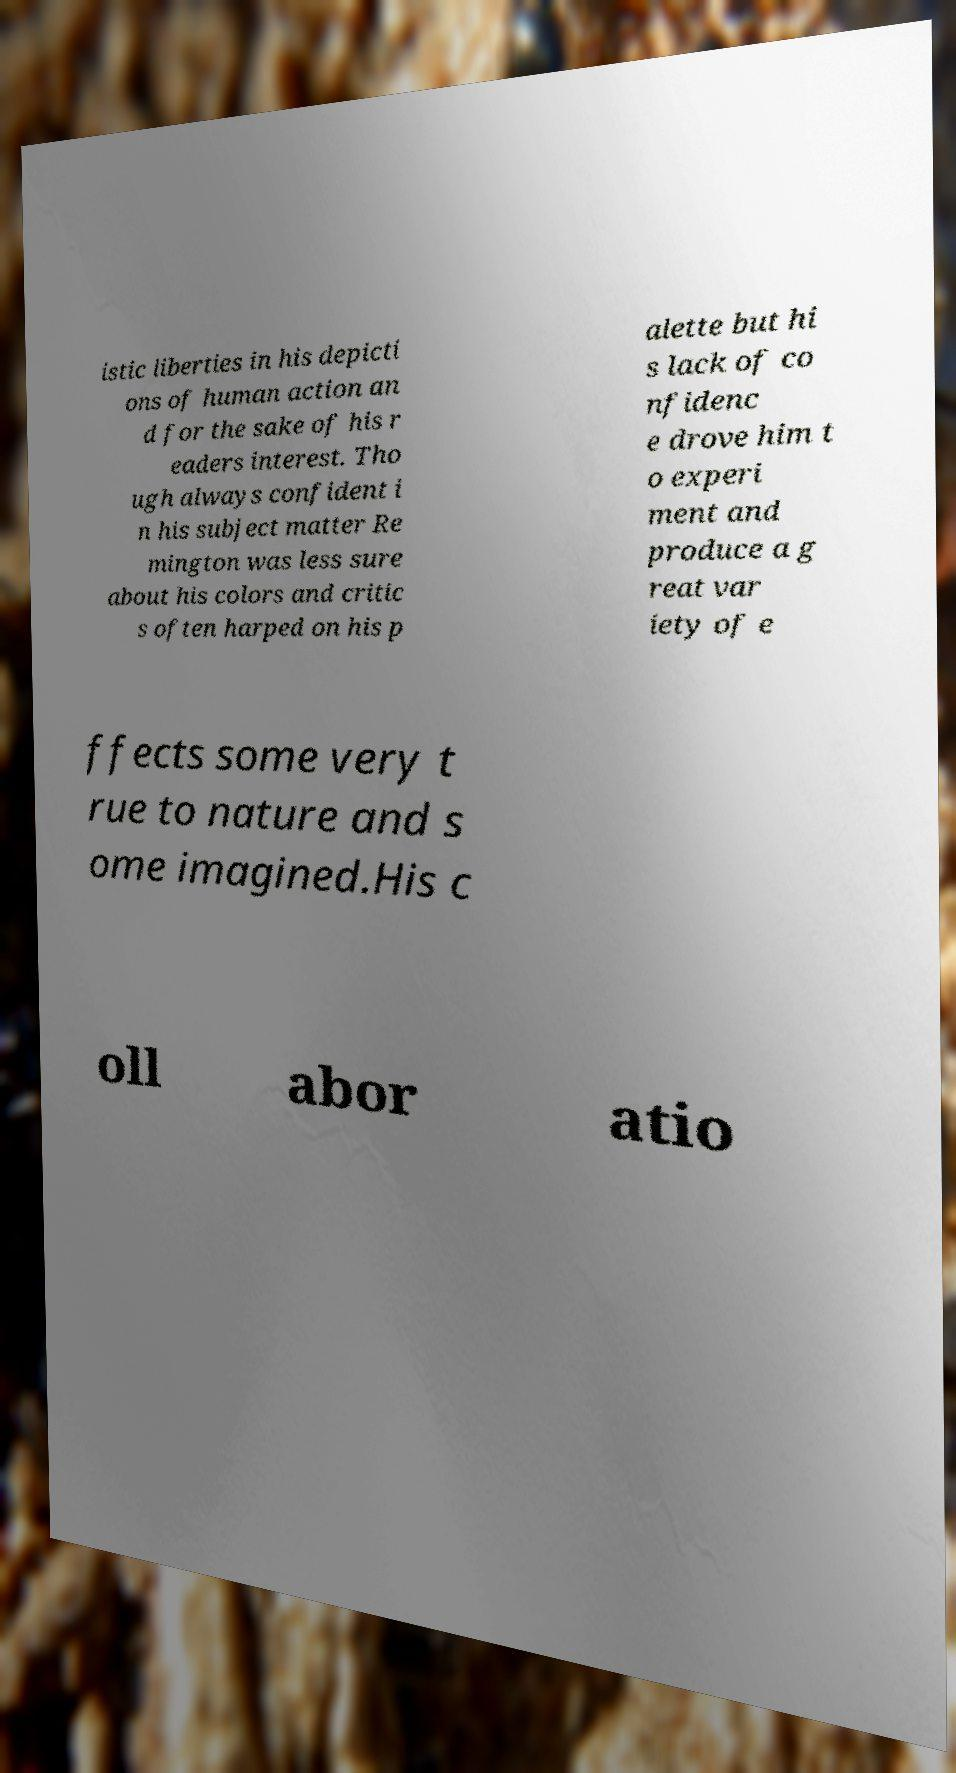For documentation purposes, I need the text within this image transcribed. Could you provide that? istic liberties in his depicti ons of human action an d for the sake of his r eaders interest. Tho ugh always confident i n his subject matter Re mington was less sure about his colors and critic s often harped on his p alette but hi s lack of co nfidenc e drove him t o experi ment and produce a g reat var iety of e ffects some very t rue to nature and s ome imagined.His c oll abor atio 